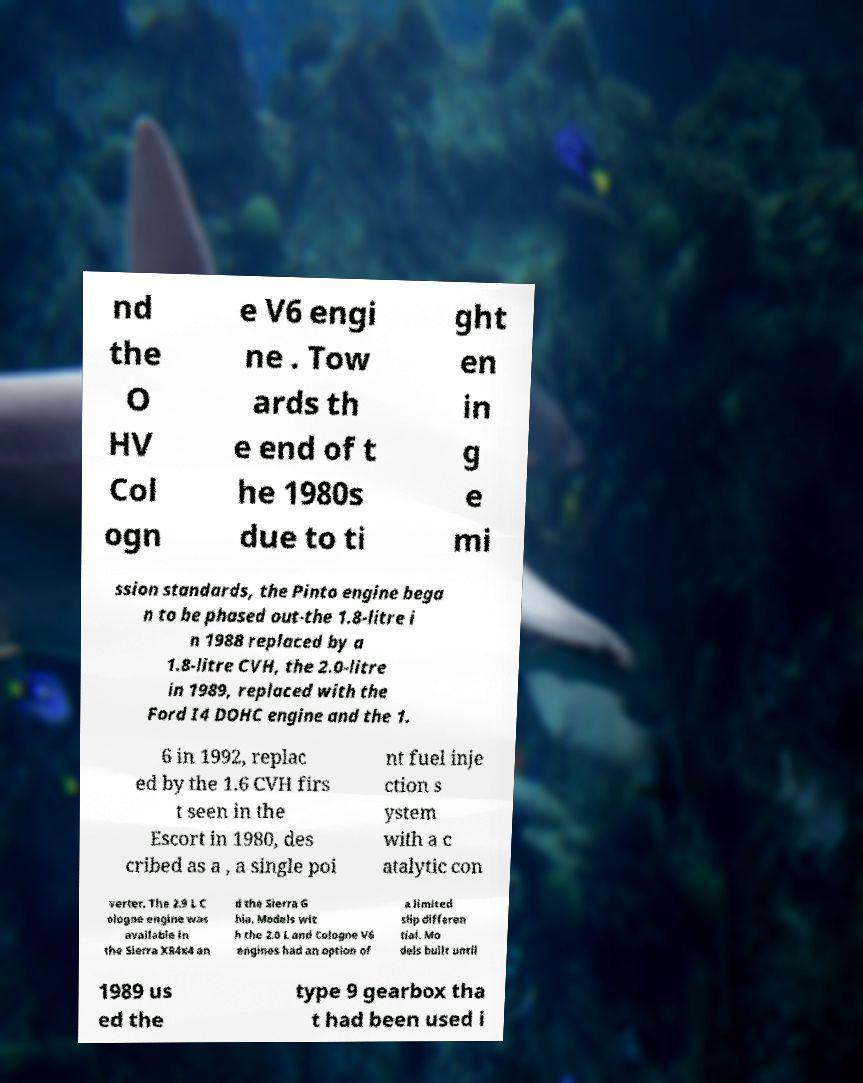Could you extract and type out the text from this image? nd the O HV Col ogn e V6 engi ne . Tow ards th e end of t he 1980s due to ti ght en in g e mi ssion standards, the Pinto engine bega n to be phased out-the 1.8-litre i n 1988 replaced by a 1.8-litre CVH, the 2.0-litre in 1989, replaced with the Ford I4 DOHC engine and the 1. 6 in 1992, replac ed by the 1.6 CVH firs t seen in the Escort in 1980, des cribed as a , a single poi nt fuel inje ction s ystem with a c atalytic con verter. The 2.9 L C ologne engine was available in the Sierra XR4x4 an d the Sierra G hia. Models wit h the 2.0 L and Cologne V6 engines had an option of a limited slip differen tial. Mo dels built until 1989 us ed the type 9 gearbox tha t had been used i 